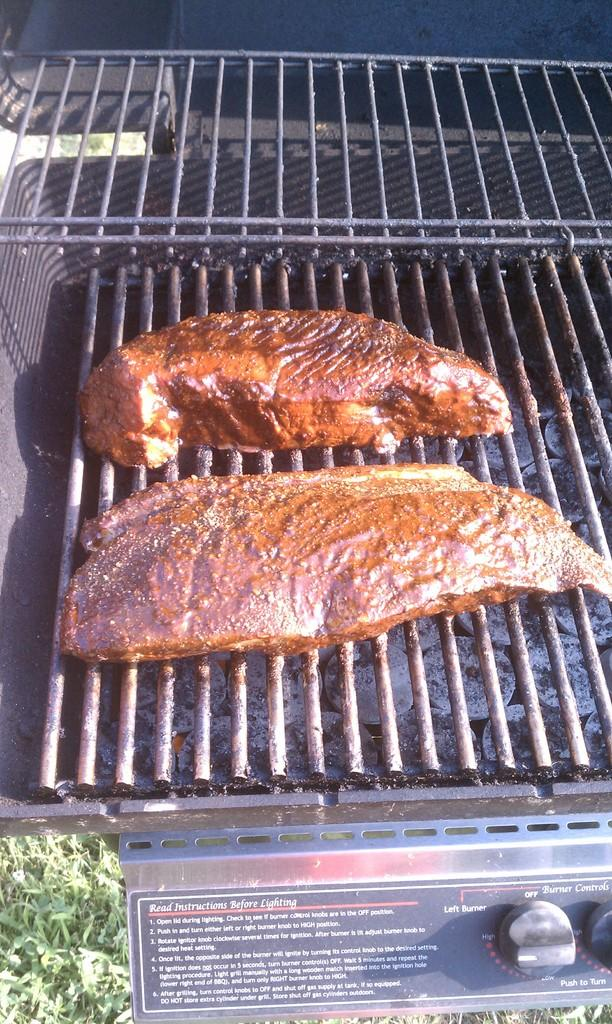Provide a one-sentence caption for the provided image. Read the instructions before lighting this grill with two pieces of meat on it. 